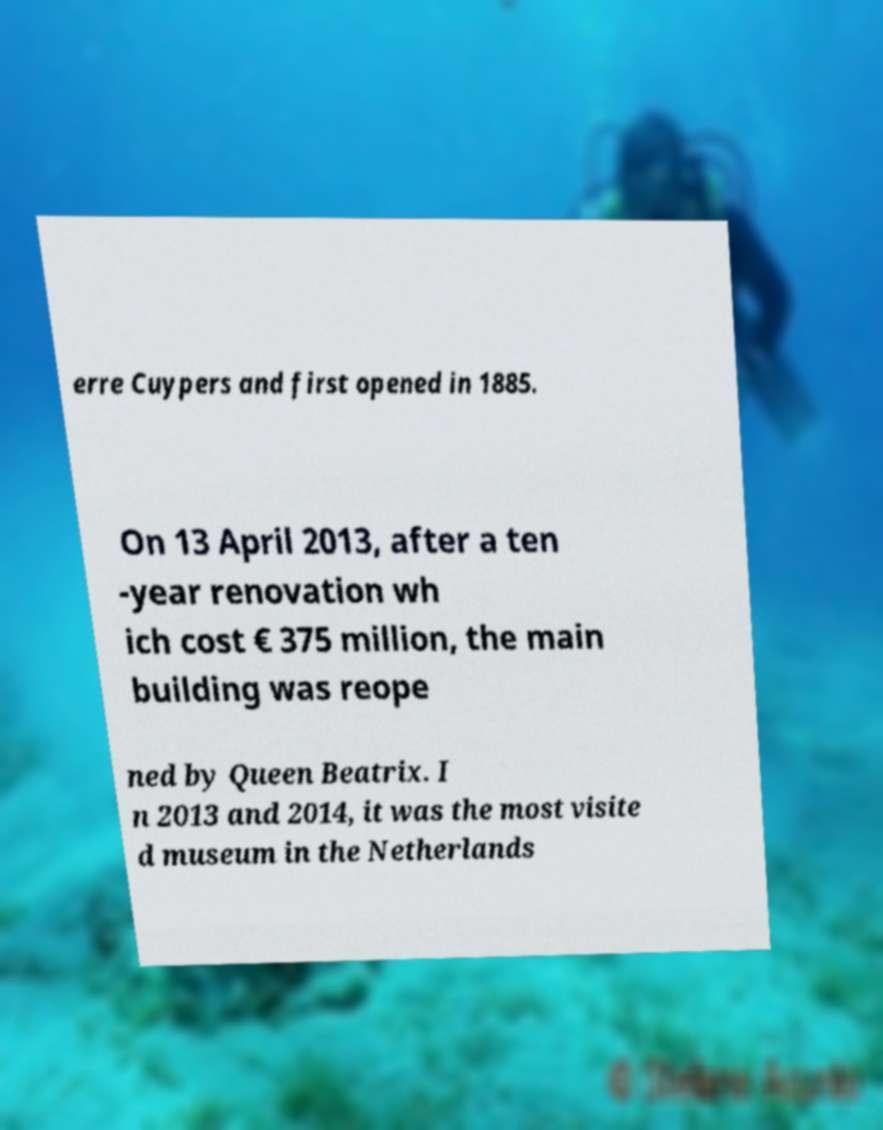Can you accurately transcribe the text from the provided image for me? erre Cuypers and first opened in 1885. On 13 April 2013, after a ten -year renovation wh ich cost € 375 million, the main building was reope ned by Queen Beatrix. I n 2013 and 2014, it was the most visite d museum in the Netherlands 